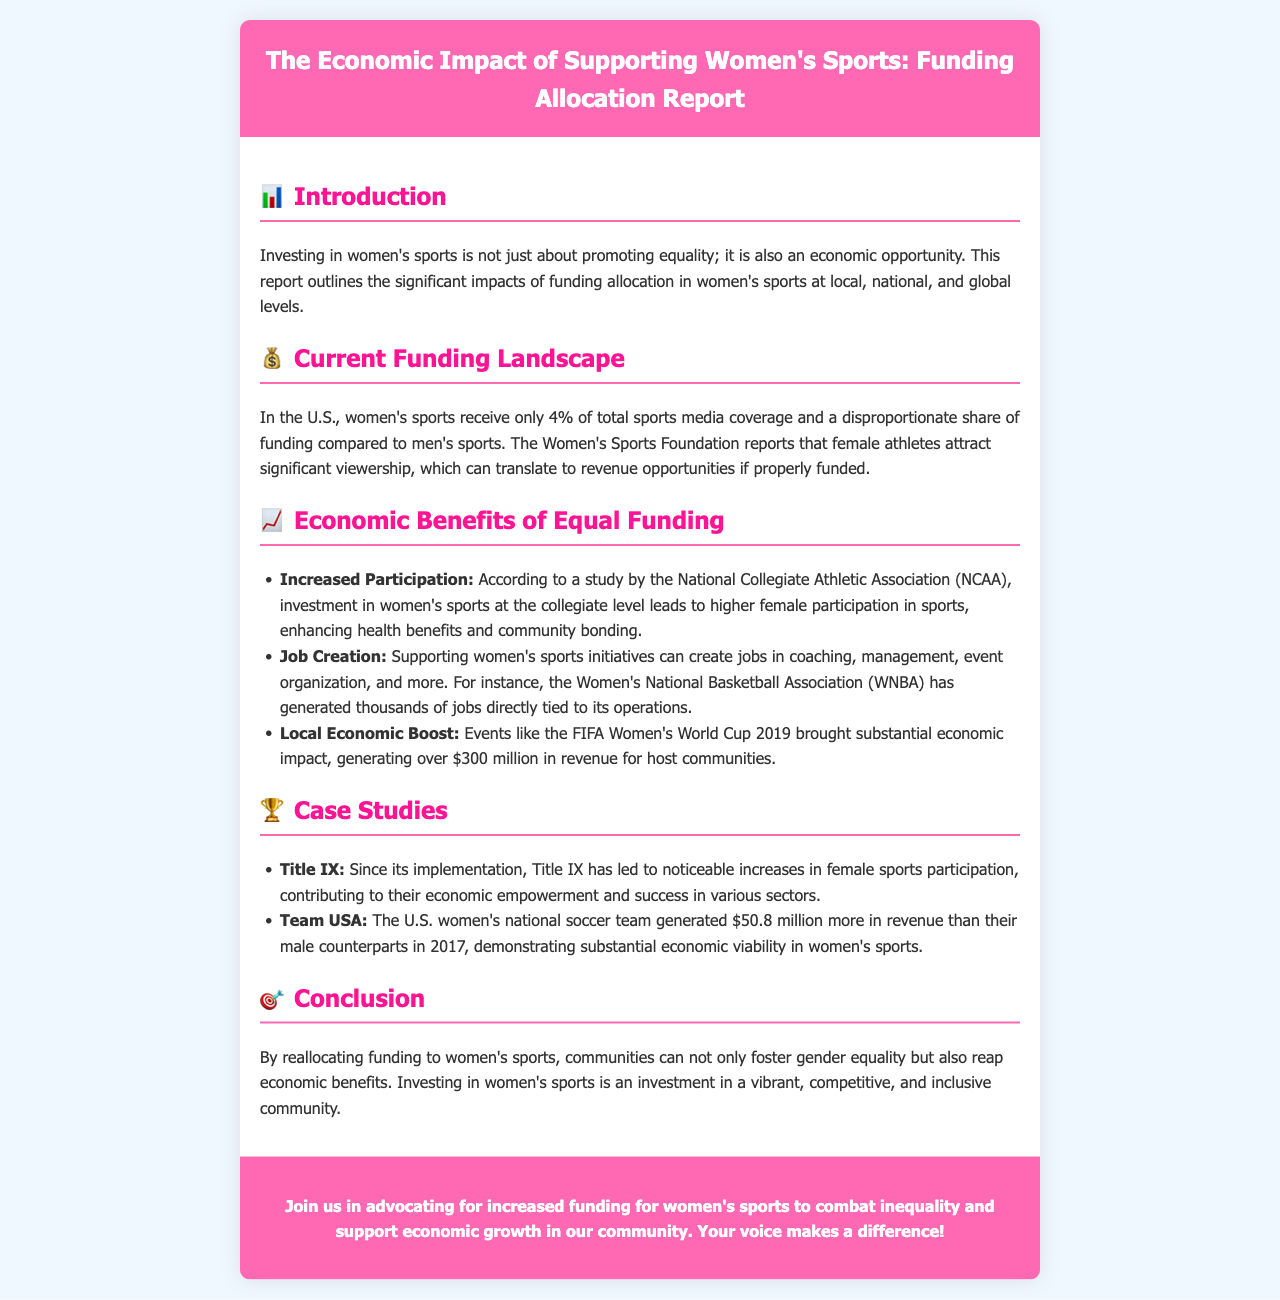What percentage of sports media coverage do women's sports receive? The document states that women's sports receive only 4% of total sports media coverage.
Answer: 4% What major economic impact did the FIFA Women's World Cup 2019 have? The document mentions that the event generated over $300 million in revenue for host communities.
Answer: $300 million Which organization reports that female athletes attract significant viewership? The Women's Sports Foundation reports on the viewership of female athletes.
Answer: Women's Sports Foundation What is the result of Title IX's implementation mentioned in the document? Title IX led to noticeable increases in female sports participation.
Answer: Increased female sports participation How much more revenue did the U.S. women's national soccer team generate than their male counterparts in 2017? The document states that the U.S. women's national soccer team generated $50.8 million more in revenue.
Answer: $50.8 million What are two economic benefits of equal funding listed in the brochure? The document lists increased participation and job creation among the economic benefits.
Answer: Increased participation and job creation What color is the brochure's header background? The header background color of the brochure is pink, specifically #ff69b4.
Answer: Pink What is the primary purpose of the document? The document aims to outline the economic impact of supporting women's sports through funding allocation.
Answer: Economic impact of supporting women's sports 